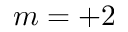Convert formula to latex. <formula><loc_0><loc_0><loc_500><loc_500>m = + 2</formula> 